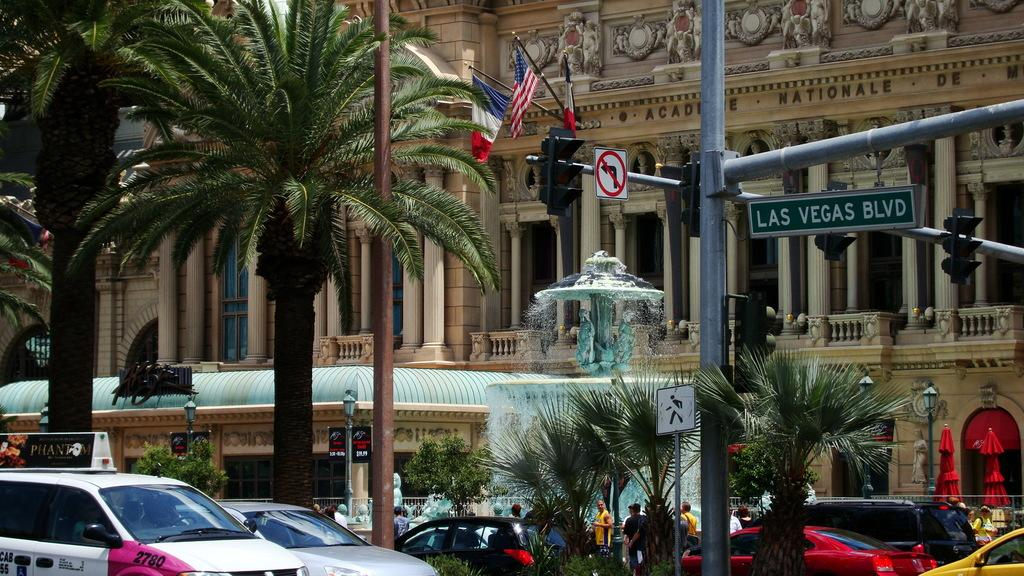What is the main feature at the center of the image? There is a fountain at the center of the image. What are the people in the image doing? The people in the image are walking on the road. What type of vehicles can be seen in the image? Cars are present in the image. What type of vegetation is visible in the image? Trees are visible in the image. What type of structures are present in the image? There are buildings in the image. What type of lighting is present in the image? Street lights are present in the image. What type of traffic control device is visible in the image? A traffic signal is visible in the image. What type of decorative or symbolic objects are present in the image? Flags are present in the image. What type of produce is being sold at the fountain in the image? There is no produce being sold at the fountain in the image; it is a decorative feature. 